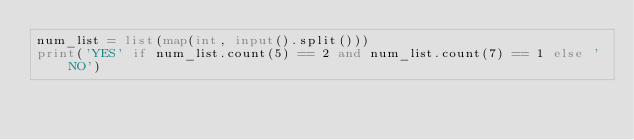Convert code to text. <code><loc_0><loc_0><loc_500><loc_500><_Python_>num_list = list(map(int, input().split()))
print('YES' if num_list.count(5) == 2 and num_list.count(7) == 1 else 'NO')
</code> 